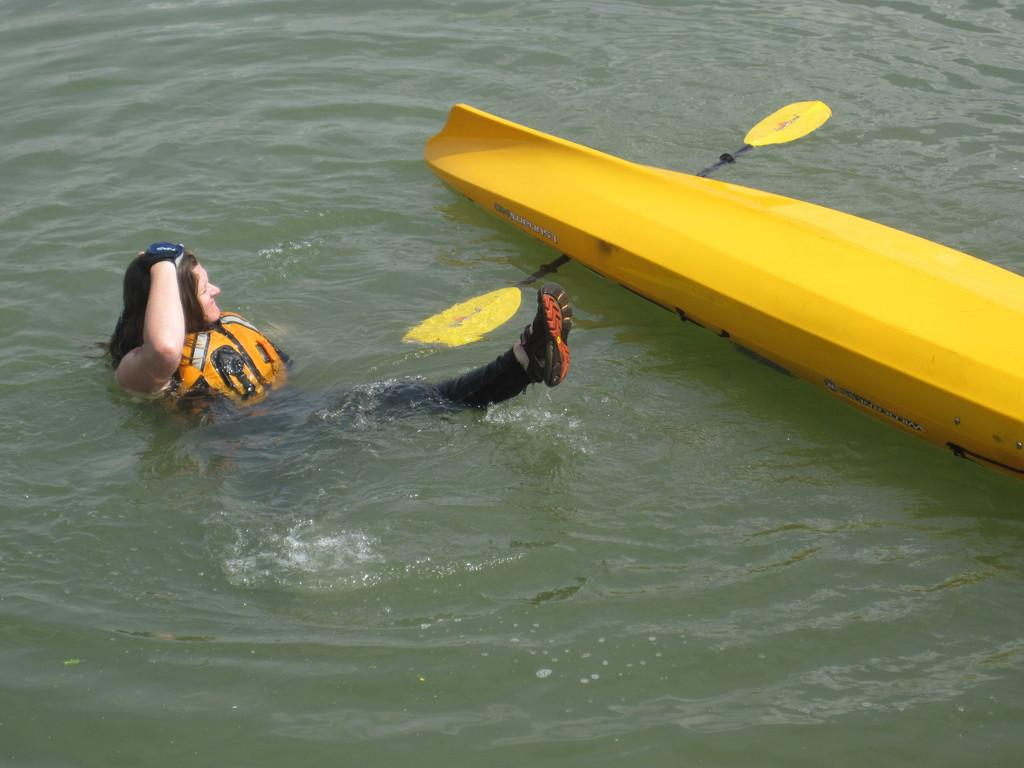What is the woman in the image doing? The woman is in the water in the center of the image. What is located in front of the woman? There is a surf boat in front of the woman. What color is the surf boat? The surf boat is yellow in color. What type of health competition is the woman participating in? There is no indication of a health competition in the image; it simply shows a woman in the water and a yellow surf boat. 